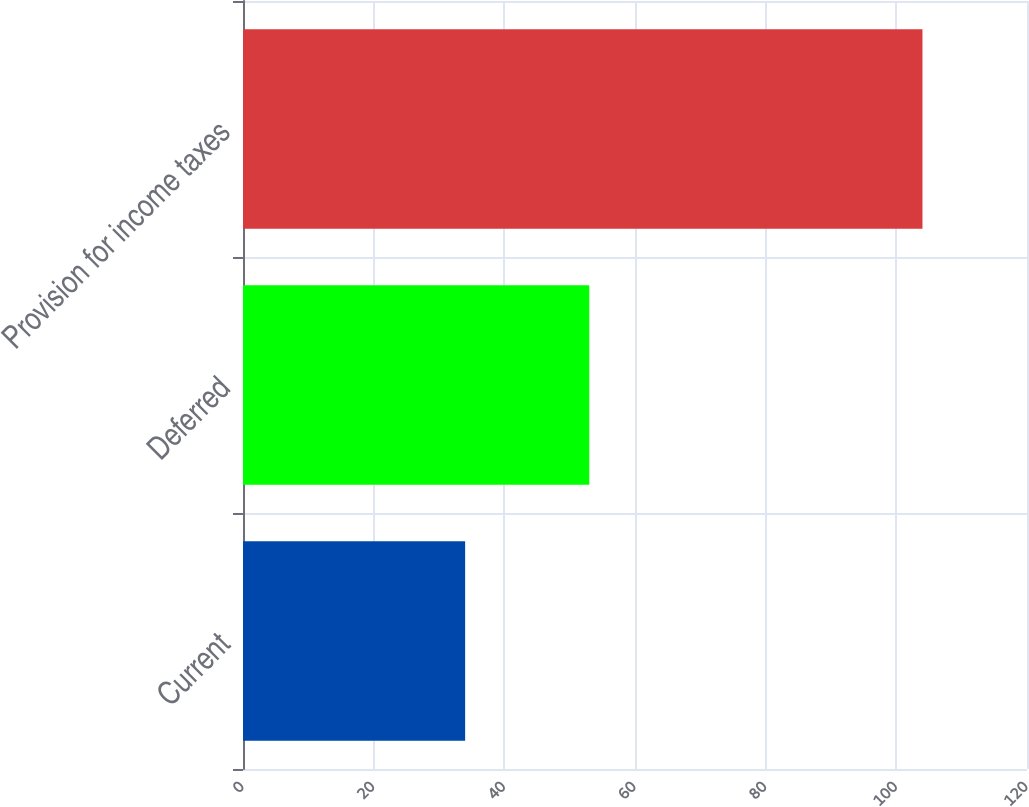Convert chart. <chart><loc_0><loc_0><loc_500><loc_500><bar_chart><fcel>Current<fcel>Deferred<fcel>Provision for income taxes<nl><fcel>34<fcel>53<fcel>104<nl></chart> 